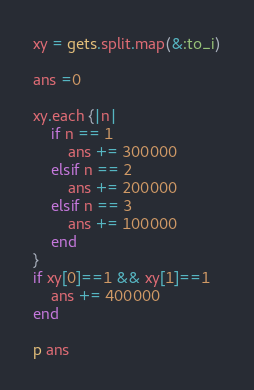Convert code to text. <code><loc_0><loc_0><loc_500><loc_500><_Ruby_>xy = gets.split.map(&:to_i)

ans =0

xy.each {|n|
    if n == 1
        ans += 300000
    elsif n == 2
        ans += 200000
    elsif n == 3
        ans += 100000
    end
}
if xy[0]==1 && xy[1]==1
    ans += 400000
end

p ans


</code> 